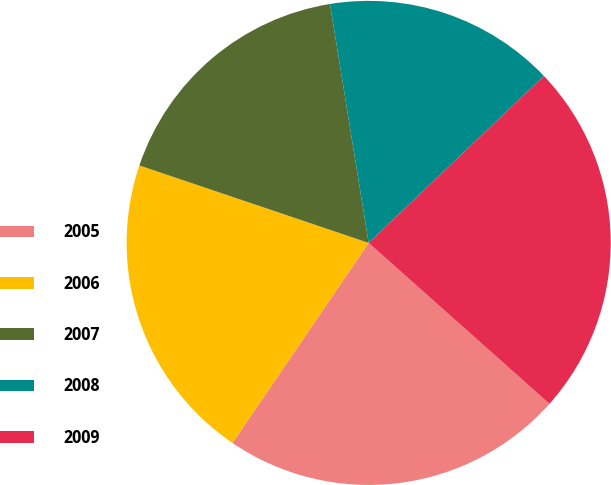Convert chart to OTSL. <chart><loc_0><loc_0><loc_500><loc_500><pie_chart><fcel>2005<fcel>2006<fcel>2007<fcel>2008<fcel>2009<nl><fcel>22.94%<fcel>20.67%<fcel>17.26%<fcel>15.44%<fcel>23.69%<nl></chart> 